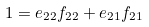<formula> <loc_0><loc_0><loc_500><loc_500>1 = e _ { 2 2 } f _ { 2 2 } + e _ { 2 1 } f _ { 2 1 }</formula> 